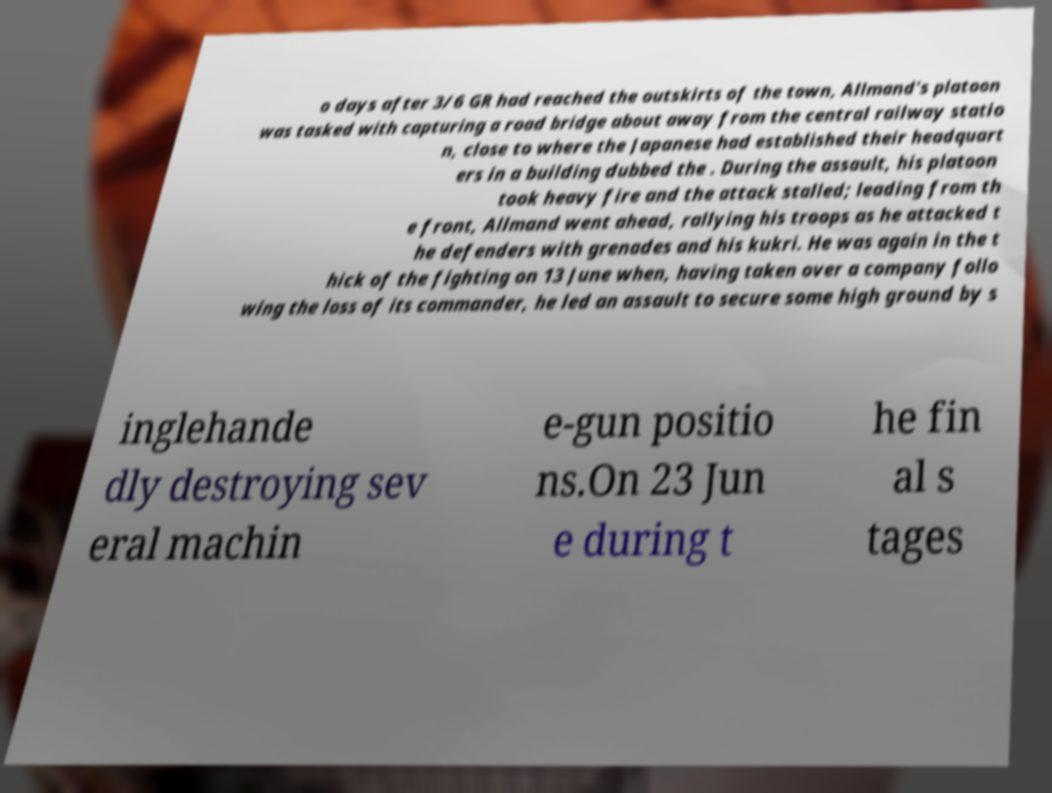Could you extract and type out the text from this image? o days after 3/6 GR had reached the outskirts of the town, Allmand's platoon was tasked with capturing a road bridge about away from the central railway statio n, close to where the Japanese had established their headquart ers in a building dubbed the . During the assault, his platoon took heavy fire and the attack stalled; leading from th e front, Allmand went ahead, rallying his troops as he attacked t he defenders with grenades and his kukri. He was again in the t hick of the fighting on 13 June when, having taken over a company follo wing the loss of its commander, he led an assault to secure some high ground by s inglehande dly destroying sev eral machin e-gun positio ns.On 23 Jun e during t he fin al s tages 